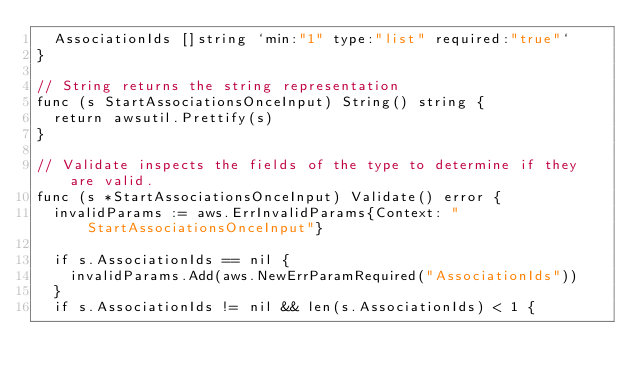Convert code to text. <code><loc_0><loc_0><loc_500><loc_500><_Go_>	AssociationIds []string `min:"1" type:"list" required:"true"`
}

// String returns the string representation
func (s StartAssociationsOnceInput) String() string {
	return awsutil.Prettify(s)
}

// Validate inspects the fields of the type to determine if they are valid.
func (s *StartAssociationsOnceInput) Validate() error {
	invalidParams := aws.ErrInvalidParams{Context: "StartAssociationsOnceInput"}

	if s.AssociationIds == nil {
		invalidParams.Add(aws.NewErrParamRequired("AssociationIds"))
	}
	if s.AssociationIds != nil && len(s.AssociationIds) < 1 {</code> 